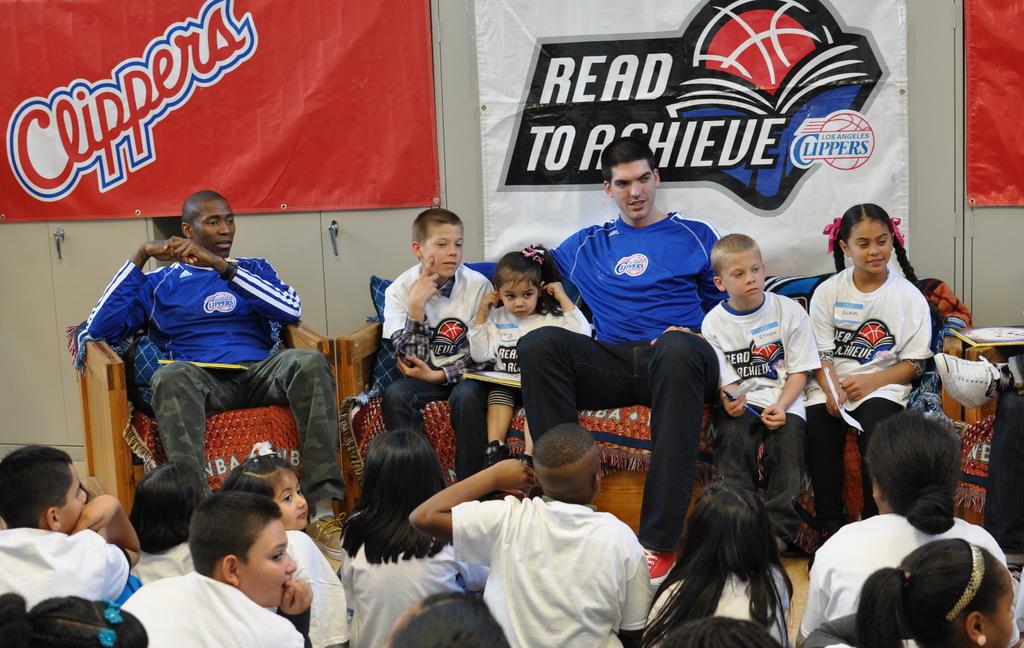What nba team is assisting with this reading program?
Give a very brief answer. Clippers. What is the name of the reading program?
Offer a terse response. Read to achieve. 